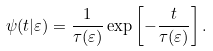Convert formula to latex. <formula><loc_0><loc_0><loc_500><loc_500>\psi ( t | \varepsilon ) = \frac { 1 } { \tau ( \varepsilon ) } \exp \left [ - \frac { t } { \tau ( \varepsilon ) } \right ] .</formula> 